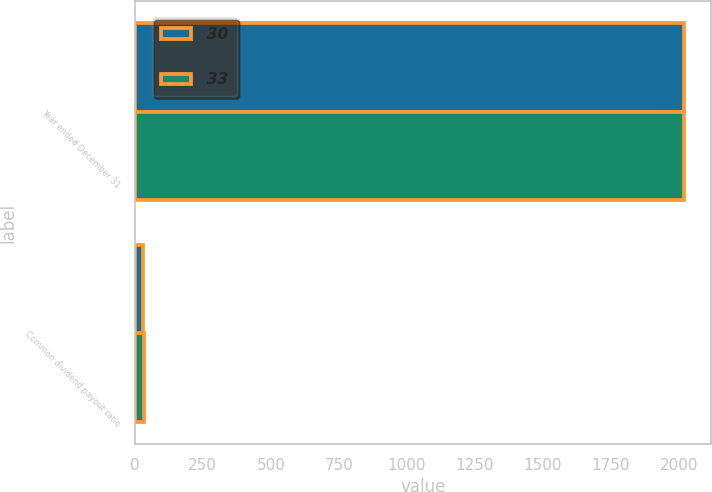Convert chart to OTSL. <chart><loc_0><loc_0><loc_500><loc_500><stacked_bar_chart><ecel><fcel>Year ended December 31<fcel>Common dividend payout ratio<nl><fcel>30<fcel>2018<fcel>30<nl><fcel>33<fcel>2017<fcel>33<nl></chart> 